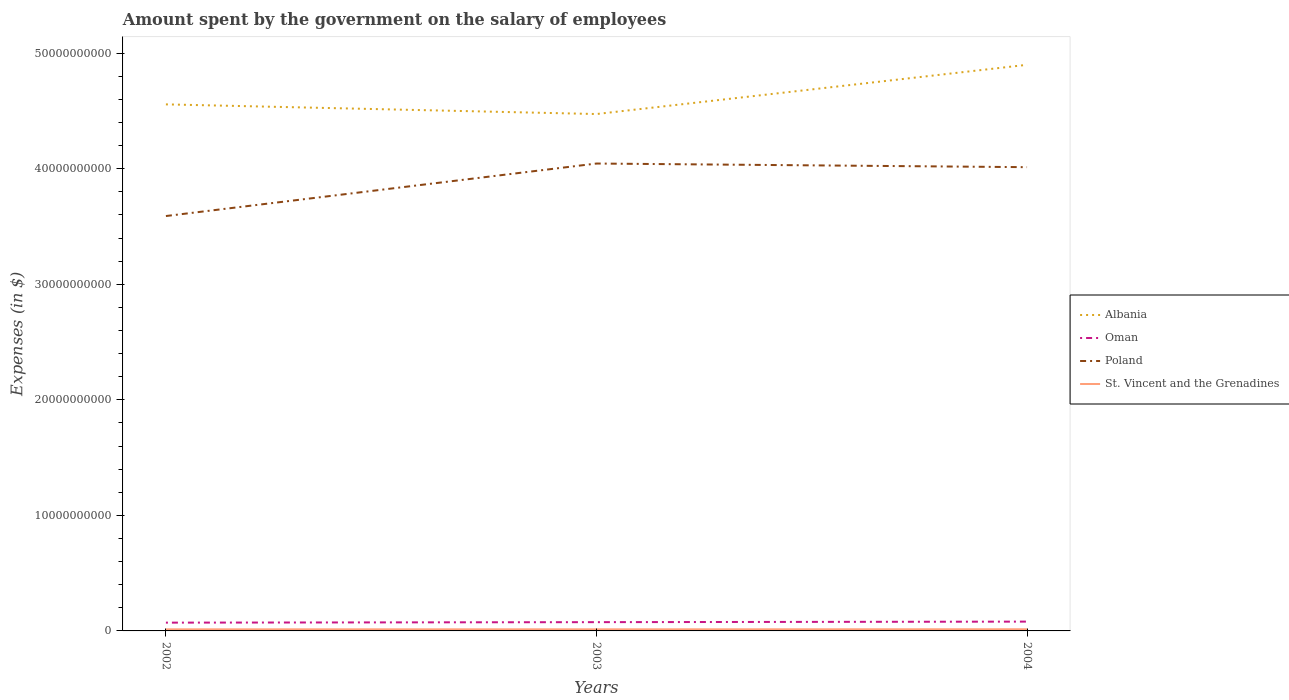Does the line corresponding to Albania intersect with the line corresponding to Oman?
Your response must be concise. No. Is the number of lines equal to the number of legend labels?
Keep it short and to the point. Yes. Across all years, what is the maximum amount spent on the salary of employees by the government in Albania?
Your response must be concise. 4.47e+1. In which year was the amount spent on the salary of employees by the government in Oman maximum?
Give a very brief answer. 2002. What is the total amount spent on the salary of employees by the government in Albania in the graph?
Provide a succinct answer. 8.36e+08. What is the difference between the highest and the second highest amount spent on the salary of employees by the government in Poland?
Make the answer very short. 4.54e+09. Is the amount spent on the salary of employees by the government in Oman strictly greater than the amount spent on the salary of employees by the government in St. Vincent and the Grenadines over the years?
Offer a terse response. No. How many lines are there?
Your answer should be compact. 4. How many years are there in the graph?
Your answer should be compact. 3. Does the graph contain any zero values?
Provide a succinct answer. No. Does the graph contain grids?
Your answer should be compact. No. Where does the legend appear in the graph?
Provide a short and direct response. Center right. How are the legend labels stacked?
Provide a succinct answer. Vertical. What is the title of the graph?
Your answer should be compact. Amount spent by the government on the salary of employees. Does "Bahamas" appear as one of the legend labels in the graph?
Provide a short and direct response. No. What is the label or title of the X-axis?
Your answer should be compact. Years. What is the label or title of the Y-axis?
Your answer should be very brief. Expenses (in $). What is the Expenses (in $) in Albania in 2002?
Keep it short and to the point. 4.56e+1. What is the Expenses (in $) in Oman in 2002?
Provide a short and direct response. 7.16e+08. What is the Expenses (in $) of Poland in 2002?
Offer a very short reply. 3.59e+1. What is the Expenses (in $) in St. Vincent and the Grenadines in 2002?
Your answer should be compact. 1.38e+08. What is the Expenses (in $) in Albania in 2003?
Ensure brevity in your answer.  4.47e+1. What is the Expenses (in $) in Oman in 2003?
Provide a short and direct response. 7.59e+08. What is the Expenses (in $) in Poland in 2003?
Your answer should be compact. 4.05e+1. What is the Expenses (in $) in St. Vincent and the Grenadines in 2003?
Your answer should be very brief. 1.39e+08. What is the Expenses (in $) in Albania in 2004?
Your answer should be very brief. 4.90e+1. What is the Expenses (in $) in Oman in 2004?
Your answer should be very brief. 8.06e+08. What is the Expenses (in $) in Poland in 2004?
Provide a short and direct response. 4.01e+1. What is the Expenses (in $) of St. Vincent and the Grenadines in 2004?
Keep it short and to the point. 1.45e+08. Across all years, what is the maximum Expenses (in $) of Albania?
Ensure brevity in your answer.  4.90e+1. Across all years, what is the maximum Expenses (in $) in Oman?
Give a very brief answer. 8.06e+08. Across all years, what is the maximum Expenses (in $) in Poland?
Give a very brief answer. 4.05e+1. Across all years, what is the maximum Expenses (in $) in St. Vincent and the Grenadines?
Make the answer very short. 1.45e+08. Across all years, what is the minimum Expenses (in $) of Albania?
Your answer should be very brief. 4.47e+1. Across all years, what is the minimum Expenses (in $) in Oman?
Your answer should be compact. 7.16e+08. Across all years, what is the minimum Expenses (in $) of Poland?
Offer a terse response. 3.59e+1. Across all years, what is the minimum Expenses (in $) of St. Vincent and the Grenadines?
Make the answer very short. 1.38e+08. What is the total Expenses (in $) in Albania in the graph?
Your answer should be compact. 1.39e+11. What is the total Expenses (in $) in Oman in the graph?
Provide a succinct answer. 2.28e+09. What is the total Expenses (in $) in Poland in the graph?
Keep it short and to the point. 1.16e+11. What is the total Expenses (in $) of St. Vincent and the Grenadines in the graph?
Ensure brevity in your answer.  4.22e+08. What is the difference between the Expenses (in $) in Albania in 2002 and that in 2003?
Provide a short and direct response. 8.36e+08. What is the difference between the Expenses (in $) in Oman in 2002 and that in 2003?
Your answer should be very brief. -4.25e+07. What is the difference between the Expenses (in $) in Poland in 2002 and that in 2003?
Offer a terse response. -4.54e+09. What is the difference between the Expenses (in $) in St. Vincent and the Grenadines in 2002 and that in 2003?
Provide a short and direct response. -8.00e+05. What is the difference between the Expenses (in $) in Albania in 2002 and that in 2004?
Provide a succinct answer. -3.42e+09. What is the difference between the Expenses (in $) of Oman in 2002 and that in 2004?
Your answer should be very brief. -8.92e+07. What is the difference between the Expenses (in $) of Poland in 2002 and that in 2004?
Offer a terse response. -4.23e+09. What is the difference between the Expenses (in $) in St. Vincent and the Grenadines in 2002 and that in 2004?
Keep it short and to the point. -6.50e+06. What is the difference between the Expenses (in $) in Albania in 2003 and that in 2004?
Ensure brevity in your answer.  -4.26e+09. What is the difference between the Expenses (in $) of Oman in 2003 and that in 2004?
Ensure brevity in your answer.  -4.67e+07. What is the difference between the Expenses (in $) of Poland in 2003 and that in 2004?
Ensure brevity in your answer.  3.15e+08. What is the difference between the Expenses (in $) in St. Vincent and the Grenadines in 2003 and that in 2004?
Provide a short and direct response. -5.70e+06. What is the difference between the Expenses (in $) in Albania in 2002 and the Expenses (in $) in Oman in 2003?
Offer a terse response. 4.48e+1. What is the difference between the Expenses (in $) in Albania in 2002 and the Expenses (in $) in Poland in 2003?
Provide a succinct answer. 5.12e+09. What is the difference between the Expenses (in $) of Albania in 2002 and the Expenses (in $) of St. Vincent and the Grenadines in 2003?
Provide a short and direct response. 4.54e+1. What is the difference between the Expenses (in $) of Oman in 2002 and the Expenses (in $) of Poland in 2003?
Keep it short and to the point. -3.97e+1. What is the difference between the Expenses (in $) in Oman in 2002 and the Expenses (in $) in St. Vincent and the Grenadines in 2003?
Give a very brief answer. 5.77e+08. What is the difference between the Expenses (in $) of Poland in 2002 and the Expenses (in $) of St. Vincent and the Grenadines in 2003?
Ensure brevity in your answer.  3.58e+1. What is the difference between the Expenses (in $) of Albania in 2002 and the Expenses (in $) of Oman in 2004?
Make the answer very short. 4.48e+1. What is the difference between the Expenses (in $) of Albania in 2002 and the Expenses (in $) of Poland in 2004?
Your answer should be very brief. 5.44e+09. What is the difference between the Expenses (in $) in Albania in 2002 and the Expenses (in $) in St. Vincent and the Grenadines in 2004?
Offer a very short reply. 4.54e+1. What is the difference between the Expenses (in $) in Oman in 2002 and the Expenses (in $) in Poland in 2004?
Offer a terse response. -3.94e+1. What is the difference between the Expenses (in $) of Oman in 2002 and the Expenses (in $) of St. Vincent and the Grenadines in 2004?
Offer a very short reply. 5.72e+08. What is the difference between the Expenses (in $) in Poland in 2002 and the Expenses (in $) in St. Vincent and the Grenadines in 2004?
Keep it short and to the point. 3.58e+1. What is the difference between the Expenses (in $) in Albania in 2003 and the Expenses (in $) in Oman in 2004?
Make the answer very short. 4.39e+1. What is the difference between the Expenses (in $) in Albania in 2003 and the Expenses (in $) in Poland in 2004?
Provide a succinct answer. 4.60e+09. What is the difference between the Expenses (in $) of Albania in 2003 and the Expenses (in $) of St. Vincent and the Grenadines in 2004?
Provide a short and direct response. 4.46e+1. What is the difference between the Expenses (in $) of Oman in 2003 and the Expenses (in $) of Poland in 2004?
Ensure brevity in your answer.  -3.94e+1. What is the difference between the Expenses (in $) of Oman in 2003 and the Expenses (in $) of St. Vincent and the Grenadines in 2004?
Your response must be concise. 6.14e+08. What is the difference between the Expenses (in $) of Poland in 2003 and the Expenses (in $) of St. Vincent and the Grenadines in 2004?
Make the answer very short. 4.03e+1. What is the average Expenses (in $) in Albania per year?
Make the answer very short. 4.64e+1. What is the average Expenses (in $) in Oman per year?
Keep it short and to the point. 7.60e+08. What is the average Expenses (in $) of Poland per year?
Make the answer very short. 3.88e+1. What is the average Expenses (in $) in St. Vincent and the Grenadines per year?
Make the answer very short. 1.41e+08. In the year 2002, what is the difference between the Expenses (in $) in Albania and Expenses (in $) in Oman?
Your response must be concise. 4.49e+1. In the year 2002, what is the difference between the Expenses (in $) in Albania and Expenses (in $) in Poland?
Your answer should be compact. 9.66e+09. In the year 2002, what is the difference between the Expenses (in $) of Albania and Expenses (in $) of St. Vincent and the Grenadines?
Provide a short and direct response. 4.54e+1. In the year 2002, what is the difference between the Expenses (in $) in Oman and Expenses (in $) in Poland?
Give a very brief answer. -3.52e+1. In the year 2002, what is the difference between the Expenses (in $) in Oman and Expenses (in $) in St. Vincent and the Grenadines?
Your response must be concise. 5.78e+08. In the year 2002, what is the difference between the Expenses (in $) of Poland and Expenses (in $) of St. Vincent and the Grenadines?
Keep it short and to the point. 3.58e+1. In the year 2003, what is the difference between the Expenses (in $) of Albania and Expenses (in $) of Oman?
Provide a succinct answer. 4.40e+1. In the year 2003, what is the difference between the Expenses (in $) of Albania and Expenses (in $) of Poland?
Keep it short and to the point. 4.28e+09. In the year 2003, what is the difference between the Expenses (in $) in Albania and Expenses (in $) in St. Vincent and the Grenadines?
Give a very brief answer. 4.46e+1. In the year 2003, what is the difference between the Expenses (in $) of Oman and Expenses (in $) of Poland?
Give a very brief answer. -3.97e+1. In the year 2003, what is the difference between the Expenses (in $) in Oman and Expenses (in $) in St. Vincent and the Grenadines?
Keep it short and to the point. 6.20e+08. In the year 2003, what is the difference between the Expenses (in $) of Poland and Expenses (in $) of St. Vincent and the Grenadines?
Your answer should be very brief. 4.03e+1. In the year 2004, what is the difference between the Expenses (in $) in Albania and Expenses (in $) in Oman?
Your answer should be compact. 4.82e+1. In the year 2004, what is the difference between the Expenses (in $) in Albania and Expenses (in $) in Poland?
Provide a short and direct response. 8.86e+09. In the year 2004, what is the difference between the Expenses (in $) in Albania and Expenses (in $) in St. Vincent and the Grenadines?
Your response must be concise. 4.89e+1. In the year 2004, what is the difference between the Expenses (in $) of Oman and Expenses (in $) of Poland?
Your answer should be very brief. -3.93e+1. In the year 2004, what is the difference between the Expenses (in $) in Oman and Expenses (in $) in St. Vincent and the Grenadines?
Keep it short and to the point. 6.61e+08. In the year 2004, what is the difference between the Expenses (in $) in Poland and Expenses (in $) in St. Vincent and the Grenadines?
Offer a terse response. 4.00e+1. What is the ratio of the Expenses (in $) in Albania in 2002 to that in 2003?
Provide a short and direct response. 1.02. What is the ratio of the Expenses (in $) of Oman in 2002 to that in 2003?
Offer a very short reply. 0.94. What is the ratio of the Expenses (in $) of Poland in 2002 to that in 2003?
Provide a succinct answer. 0.89. What is the ratio of the Expenses (in $) in Albania in 2002 to that in 2004?
Give a very brief answer. 0.93. What is the ratio of the Expenses (in $) of Oman in 2002 to that in 2004?
Provide a short and direct response. 0.89. What is the ratio of the Expenses (in $) in Poland in 2002 to that in 2004?
Your response must be concise. 0.89. What is the ratio of the Expenses (in $) in St. Vincent and the Grenadines in 2002 to that in 2004?
Your answer should be very brief. 0.96. What is the ratio of the Expenses (in $) of Albania in 2003 to that in 2004?
Provide a succinct answer. 0.91. What is the ratio of the Expenses (in $) in Oman in 2003 to that in 2004?
Provide a short and direct response. 0.94. What is the ratio of the Expenses (in $) of Poland in 2003 to that in 2004?
Your response must be concise. 1.01. What is the ratio of the Expenses (in $) of St. Vincent and the Grenadines in 2003 to that in 2004?
Your answer should be very brief. 0.96. What is the difference between the highest and the second highest Expenses (in $) of Albania?
Your answer should be very brief. 3.42e+09. What is the difference between the highest and the second highest Expenses (in $) in Oman?
Provide a short and direct response. 4.67e+07. What is the difference between the highest and the second highest Expenses (in $) in Poland?
Provide a succinct answer. 3.15e+08. What is the difference between the highest and the second highest Expenses (in $) in St. Vincent and the Grenadines?
Your answer should be compact. 5.70e+06. What is the difference between the highest and the lowest Expenses (in $) of Albania?
Your answer should be very brief. 4.26e+09. What is the difference between the highest and the lowest Expenses (in $) in Oman?
Your answer should be very brief. 8.92e+07. What is the difference between the highest and the lowest Expenses (in $) of Poland?
Make the answer very short. 4.54e+09. What is the difference between the highest and the lowest Expenses (in $) in St. Vincent and the Grenadines?
Offer a terse response. 6.50e+06. 